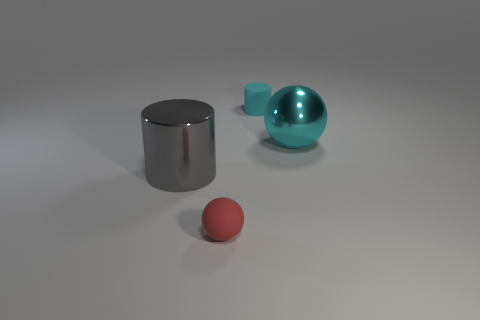Is the color of the small cylinder the same as the big metal ball?
Provide a succinct answer. Yes. There is a shiny sphere that is the same color as the matte cylinder; what is its size?
Ensure brevity in your answer.  Large. Does the cyan ball have the same size as the gray object?
Offer a terse response. Yes. Are there any big cyan spheres to the left of the big metallic thing to the left of the matte thing in front of the large sphere?
Your response must be concise. No. What is the material of the red object that is the same shape as the large cyan shiny object?
Ensure brevity in your answer.  Rubber. What is the color of the cylinder that is on the right side of the large shiny cylinder?
Provide a short and direct response. Cyan. How big is the red matte sphere?
Make the answer very short. Small. Does the cyan matte cylinder have the same size as the thing in front of the gray thing?
Give a very brief answer. Yes. What color is the big shiny sphere right of the tiny rubber object in front of the small object to the right of the red ball?
Provide a succinct answer. Cyan. Is the tiny object in front of the tiny cyan thing made of the same material as the big cyan sphere?
Your answer should be compact. No. 